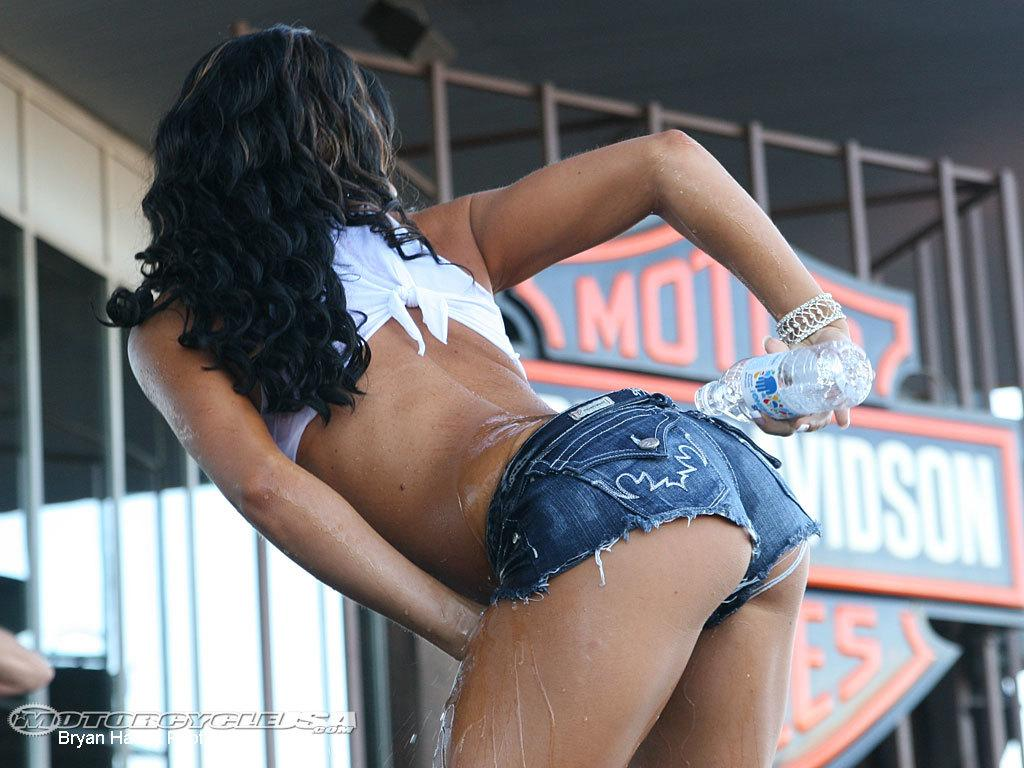Who is present in the image? There is a woman in the image. What is the woman holding in her hand? The woman is holding a bottle in her hand. What is the woman doing with the water from the bottle? The woman is pouring water on her back. What type of structure can be seen in the background of the image? There is fencing visible in the image, with boards on it. How many kittens are playing with the yam in the image? There are no kittens or yams present in the image. 